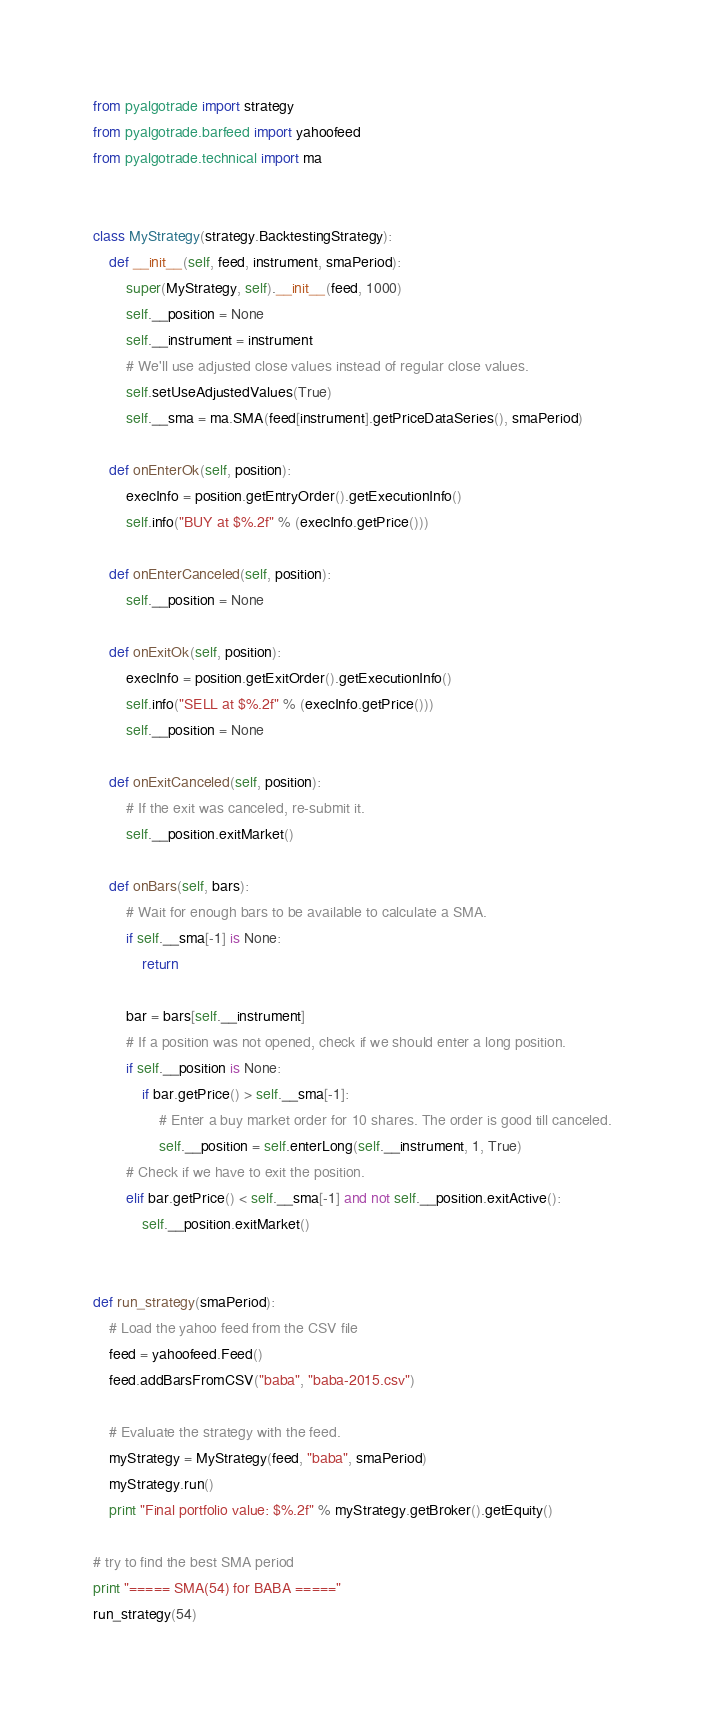Convert code to text. <code><loc_0><loc_0><loc_500><loc_500><_Python_>from pyalgotrade import strategy
from pyalgotrade.barfeed import yahoofeed
from pyalgotrade.technical import ma


class MyStrategy(strategy.BacktestingStrategy):
	def __init__(self, feed, instrument, smaPeriod):
		super(MyStrategy, self).__init__(feed, 1000)
		self.__position = None
		self.__instrument = instrument
		# We'll use adjusted close values instead of regular close values.
		self.setUseAdjustedValues(True)
		self.__sma = ma.SMA(feed[instrument].getPriceDataSeries(), smaPeriod)

	def onEnterOk(self, position):
		execInfo = position.getEntryOrder().getExecutionInfo()
		self.info("BUY at $%.2f" % (execInfo.getPrice()))

	def onEnterCanceled(self, position):
		self.__position = None

	def onExitOk(self, position):
		execInfo = position.getExitOrder().getExecutionInfo()
		self.info("SELL at $%.2f" % (execInfo.getPrice()))
		self.__position = None

	def onExitCanceled(self, position):
		# If the exit was canceled, re-submit it.
		self.__position.exitMarket()

	def onBars(self, bars):
		# Wait for enough bars to be available to calculate a SMA.
		if self.__sma[-1] is None:
			return

		bar = bars[self.__instrument]
		# If a position was not opened, check if we should enter a long position.
		if self.__position is None:
			if bar.getPrice() > self.__sma[-1]:
				# Enter a buy market order for 10 shares. The order is good till canceled.
				self.__position = self.enterLong(self.__instrument, 1, True)
		# Check if we have to exit the position.
		elif bar.getPrice() < self.__sma[-1] and not self.__position.exitActive():
			self.__position.exitMarket()


def run_strategy(smaPeriod):
	# Load the yahoo feed from the CSV file
	feed = yahoofeed.Feed()
	feed.addBarsFromCSV("baba", "baba-2015.csv")

	# Evaluate the strategy with the feed.
	myStrategy = MyStrategy(feed, "baba", smaPeriod)
	myStrategy.run()
	print "Final portfolio value: $%.2f" % myStrategy.getBroker().getEquity()

# try to find the best SMA period
print "===== SMA(54) for BABA ====="
run_strategy(54)</code> 